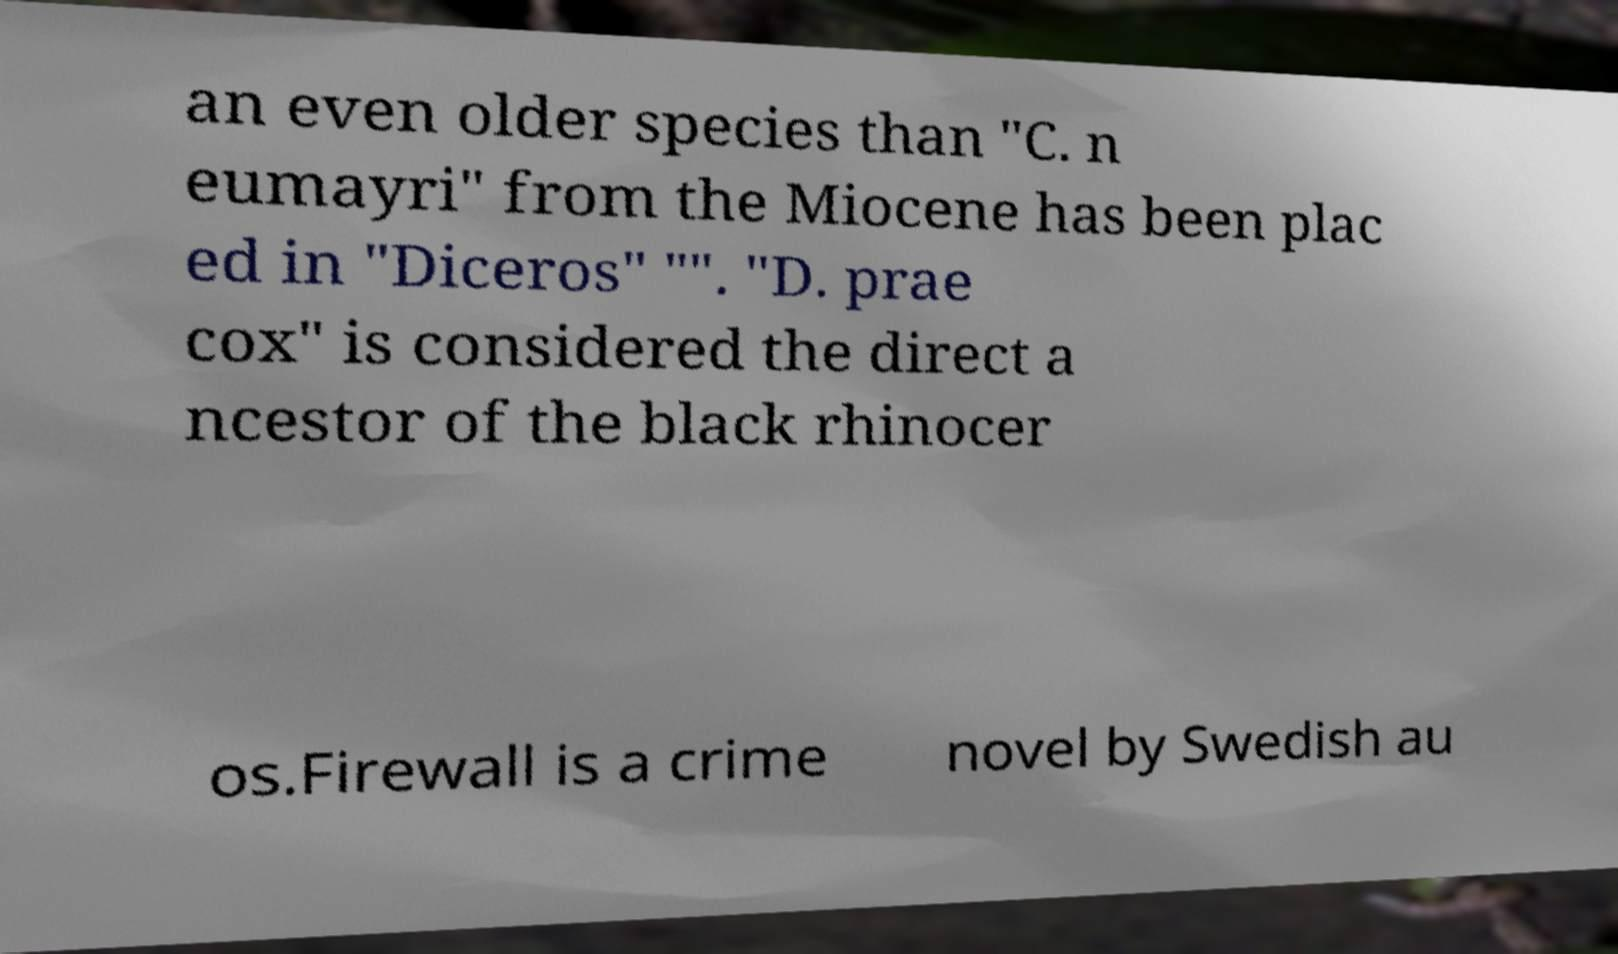Could you assist in decoding the text presented in this image and type it out clearly? an even older species than "C. n eumayri" from the Miocene has been plac ed in "Diceros" "". "D. prae cox" is considered the direct a ncestor of the black rhinocer os.Firewall is a crime novel by Swedish au 